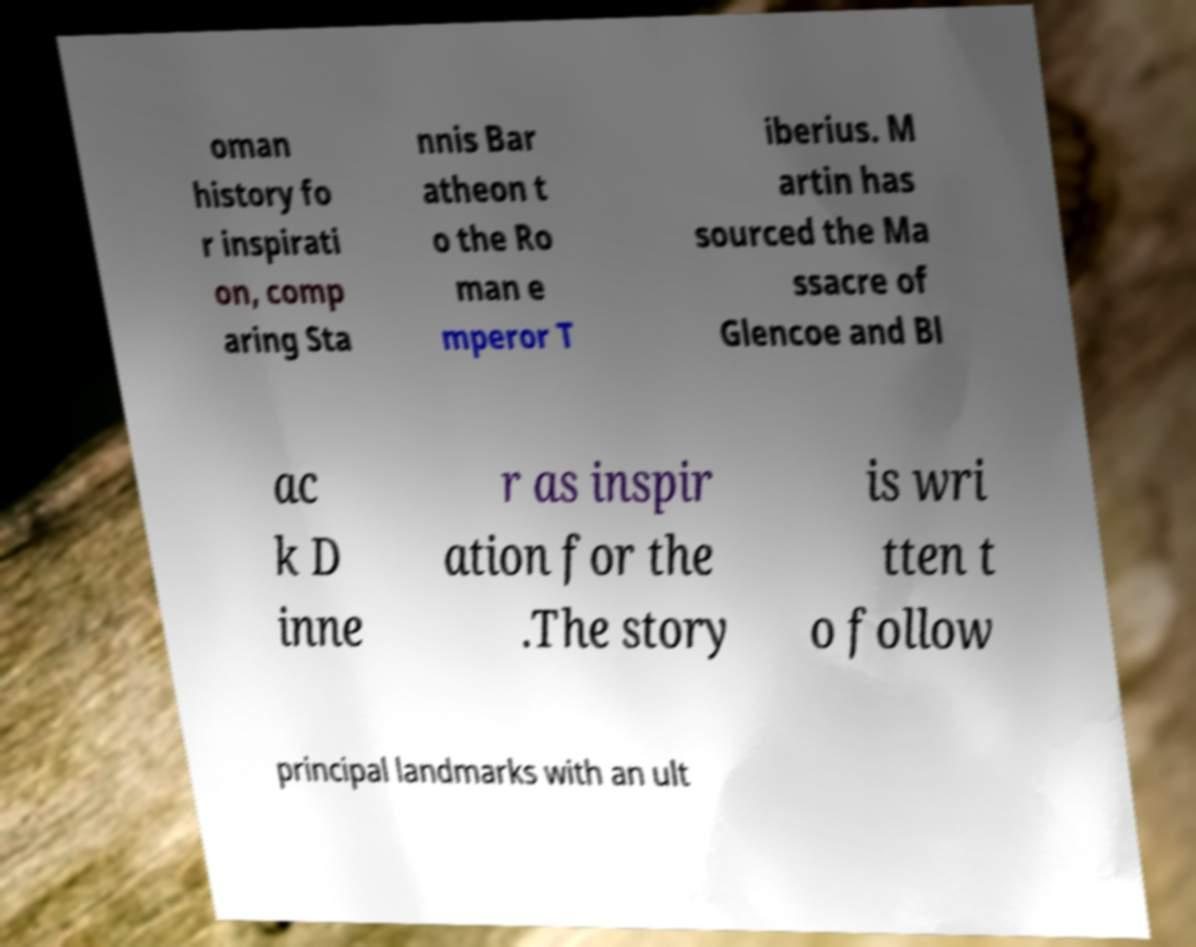Could you assist in decoding the text presented in this image and type it out clearly? oman history fo r inspirati on, comp aring Sta nnis Bar atheon t o the Ro man e mperor T iberius. M artin has sourced the Ma ssacre of Glencoe and Bl ac k D inne r as inspir ation for the .The story is wri tten t o follow principal landmarks with an ult 